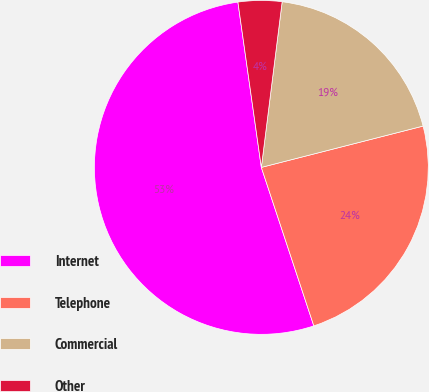Convert chart. <chart><loc_0><loc_0><loc_500><loc_500><pie_chart><fcel>Internet<fcel>Telephone<fcel>Commercial<fcel>Other<nl><fcel>52.85%<fcel>23.89%<fcel>19.03%<fcel>4.23%<nl></chart> 